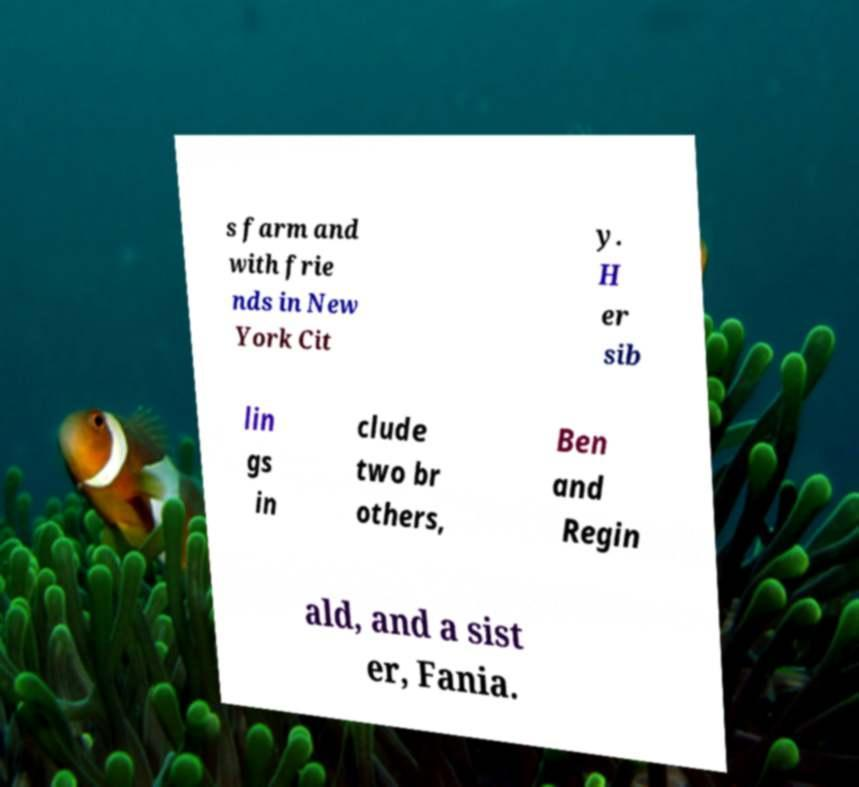Can you read and provide the text displayed in the image?This photo seems to have some interesting text. Can you extract and type it out for me? s farm and with frie nds in New York Cit y. H er sib lin gs in clude two br others, Ben and Regin ald, and a sist er, Fania. 